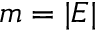<formula> <loc_0><loc_0><loc_500><loc_500>m = | E |</formula> 